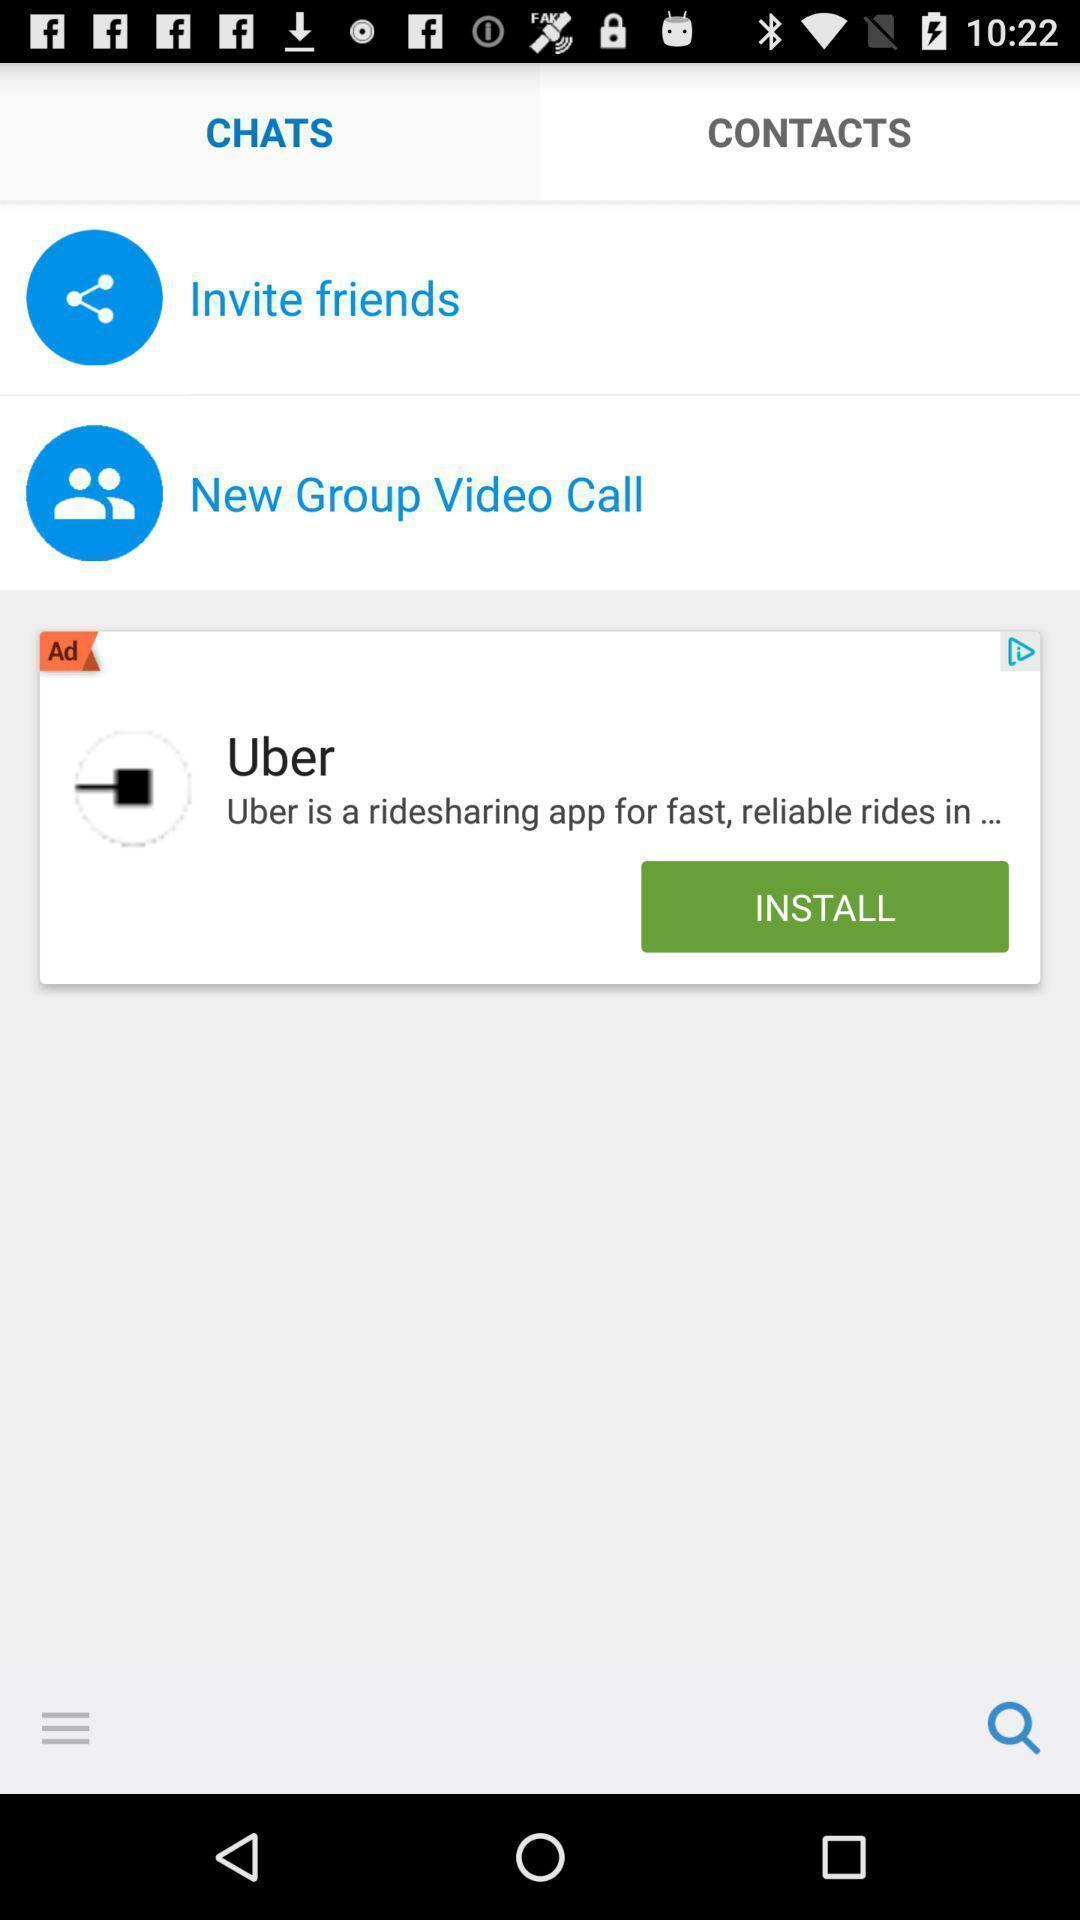Provide a description of this screenshot. Page showing chats with other options in messaging app. 